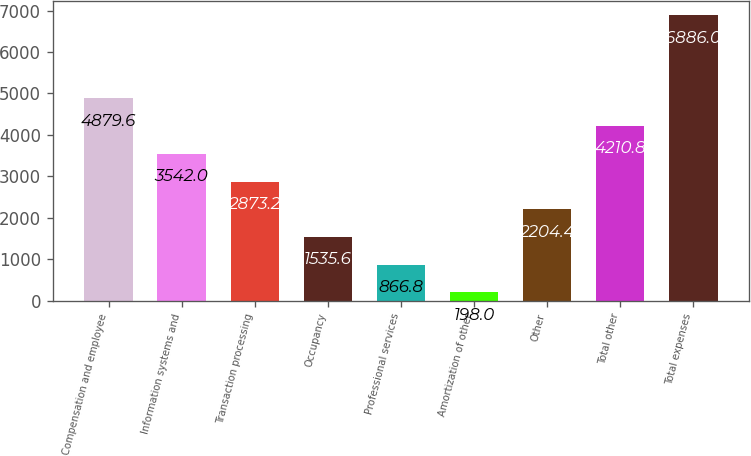Convert chart to OTSL. <chart><loc_0><loc_0><loc_500><loc_500><bar_chart><fcel>Compensation and employee<fcel>Information systems and<fcel>Transaction processing<fcel>Occupancy<fcel>Professional services<fcel>Amortization of other<fcel>Other<fcel>Total other<fcel>Total expenses<nl><fcel>4879.6<fcel>3542<fcel>2873.2<fcel>1535.6<fcel>866.8<fcel>198<fcel>2204.4<fcel>4210.8<fcel>6886<nl></chart> 